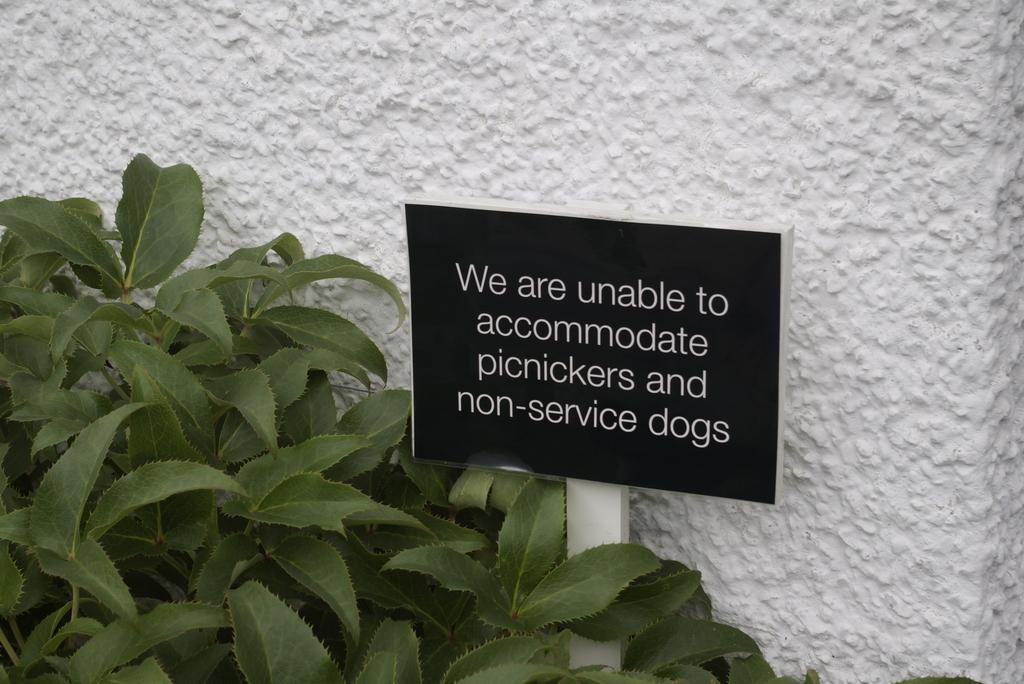What is written on the board in the image? The image contains a board with text. What type of vegetation can be seen on the left side of the image? There are leaves on the left side of the image. What can be seen in the background of the image? There is a wall visible in the background of the image. What type of bean is growing on the wall in the image? There are no beans present in the image; it features a board with text, leaves on the left side, and a wall in the background. What type of school is depicted in the image? There is no school depicted in the image. 